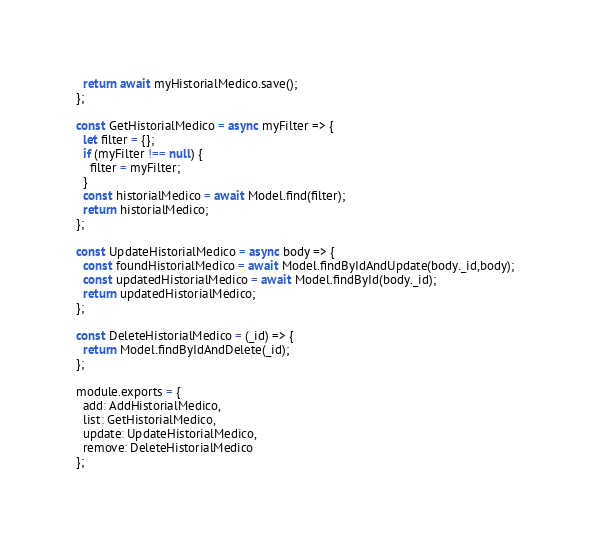Convert code to text. <code><loc_0><loc_0><loc_500><loc_500><_JavaScript_>  return await myHistorialMedico.save();
};

const GetHistorialMedico = async myFilter => {
  let filter = {};
  if (myFilter !== null) {
    filter = myFilter;
  }
  const historialMedico = await Model.find(filter);
  return historialMedico;
};

const UpdateHistorialMedico = async body => {
  const foundHistorialMedico = await Model.findByIdAndUpdate(body._id,body);
  const updatedHistorialMedico = await Model.findById(body._id);
  return updatedHistorialMedico;
};

const DeleteHistorialMedico = (_id) => {
  return Model.findByIdAndDelete(_id);
};

module.exports = {
  add: AddHistorialMedico,
  list: GetHistorialMedico,
  update: UpdateHistorialMedico,
  remove: DeleteHistorialMedico
};
</code> 